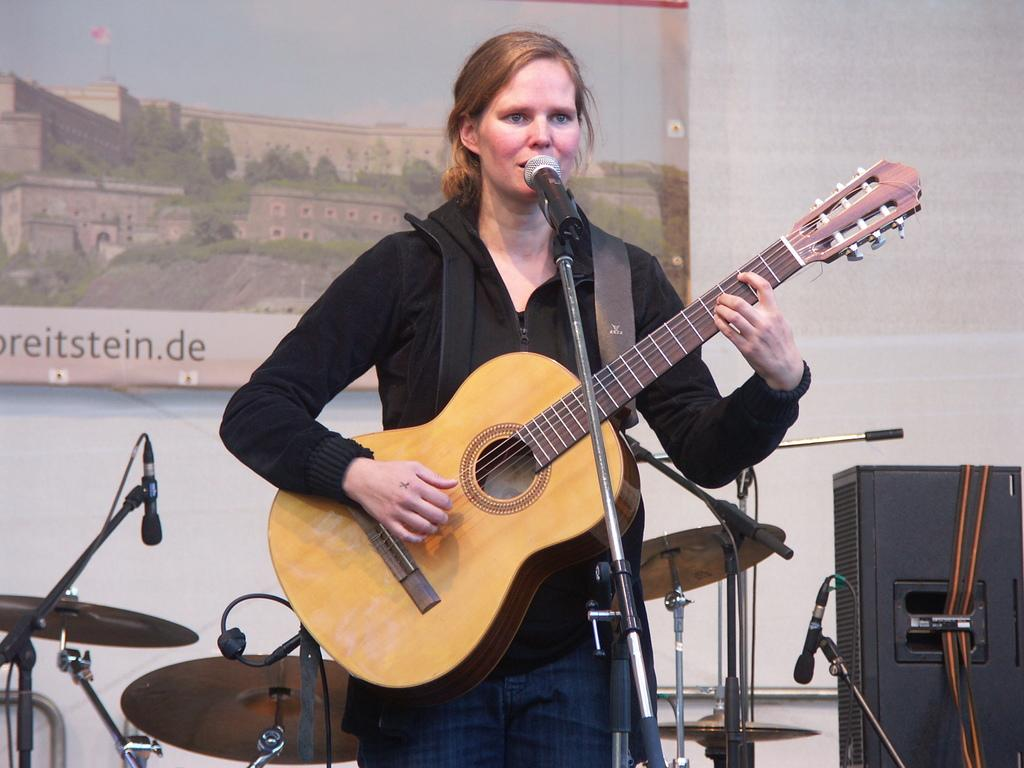Who is the main subject in the image? There is a woman in the image. What is the woman doing in the image? The woman is standing in front of a mic and holding a guitar. Can you describe the background of the image? There are additional mics, a musical instrument, a wall, and a speaker in the background of the image. What grade did the woman receive for her performance in the image? There is no indication of a performance or grade in the image; it simply shows a woman standing in front of a mic and holding a guitar. 